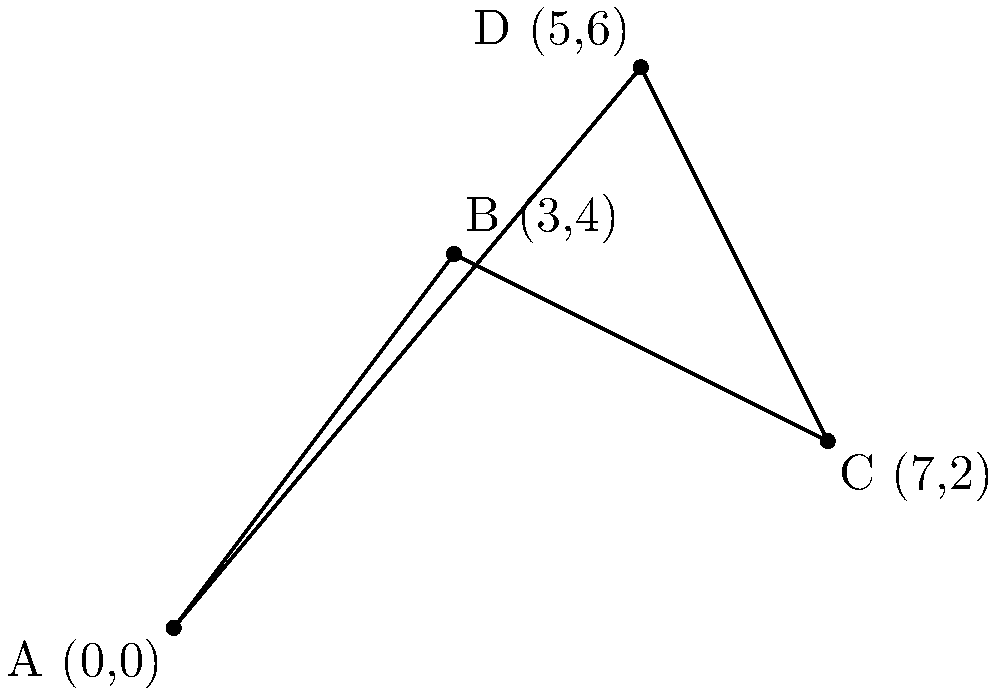As a campaign strategist, you need to determine the most efficient travel route between four key cities where your rival candidate plans to make stops. The cities are represented as points on a 2D plane: A(0,0), B(3,4), C(7,2), and D(5,6). Calculate the total distance of the shortest possible route that visits all four cities exactly once and returns to the starting point. Round your answer to two decimal places. To solve this problem, we need to:

1. Calculate the distances between all pairs of cities using the distance formula:
   $d = \sqrt{(x_2-x_1)^2 + (y_2-y_1)^2}$

2. Find the shortest route by comparing all possible permutations.

Step 1: Calculate distances

AB = $\sqrt{(3-0)^2 + (4-0)^2} = 5$
AC = $\sqrt{(7-0)^2 + (2-0)^2} = \sqrt{53} \approx 7.28$
AD = $\sqrt{(5-0)^2 + (6-0)^2} = \sqrt{61} \approx 7.81$
BC = $\sqrt{(7-3)^2 + (2-4)^2} = \sqrt{20} \approx 4.47$
BD = $\sqrt{(5-3)^2 + (6-4)^2} = \sqrt{8} \approx 2.83$
CD = $\sqrt{(5-7)^2 + (6-2)^2} = \sqrt{20} \approx 4.47$

Step 2: Compare routes

There are 3! = 6 possible routes (excluding rotations and reflections):

1. A-B-C-D-A: 5 + 4.47 + 4.47 + 7.81 = 21.75
2. A-B-D-C-A: 5 + 2.83 + 4.47 + 7.28 = 19.58
3. A-C-B-D-A: 7.28 + 4.47 + 2.83 + 7.81 = 22.39
4. A-C-D-B-A: 7.28 + 4.47 + 2.83 + 5 = 19.58
5. A-D-B-C-A: 7.81 + 2.83 + 4.47 + 7.28 = 22.39
6. A-D-C-B-A: 7.81 + 4.47 + 4.47 + 5 = 21.75

The shortest route is either A-B-D-C-A or A-C-D-B-A, both with a total distance of 19.58.
Answer: 19.58 